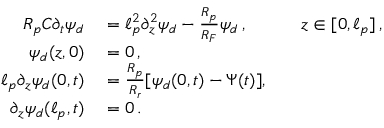Convert formula to latex. <formula><loc_0><loc_0><loc_500><loc_500>\begin{array} { r l r l } { R _ { p } C \partial _ { t } \psi _ { d } } & = \ell _ { p } ^ { 2 } \partial _ { z } ^ { 2 } \psi _ { d } - \frac { R _ { p } } { R _ { F } } \psi _ { d } \, , } & z \in [ 0 , \ell _ { p } ] \, , } \\ { \psi _ { d } ( z , 0 ) } & = 0 \, , } \\ { \ell _ { p } \partial _ { z } \psi _ { d } ( 0 , t ) } & = \frac { R _ { p } } { R _ { r } } [ \psi _ { d } ( 0 , t ) - \Psi ( t ) ] , } \\ { \partial _ { z } \psi _ { d } ( \ell _ { p } , t ) } & = 0 \, . } \end{array}</formula> 